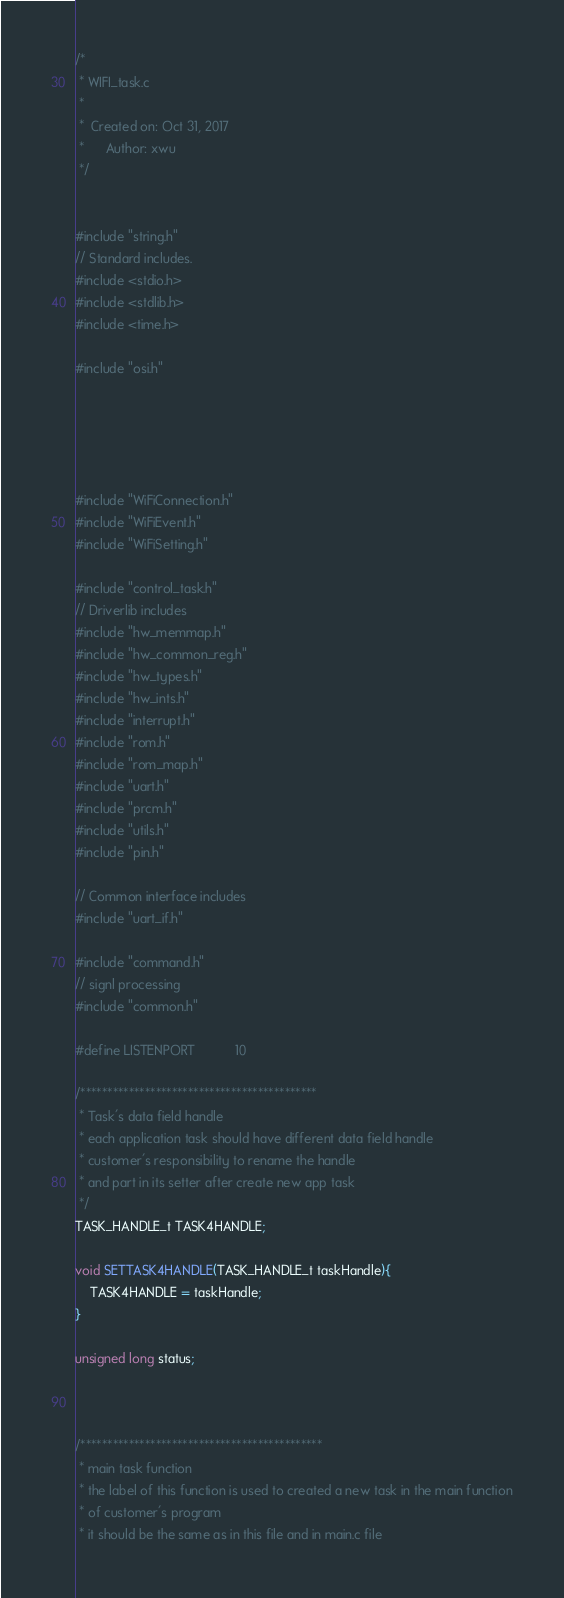<code> <loc_0><loc_0><loc_500><loc_500><_C_>/*
 * WIFI_task.c
 *
 *  Created on: Oct 31, 2017
 *      Author: xwu
 */


#include "string.h"
// Standard includes.
#include <stdio.h>
#include <stdlib.h>
#include <time.h>

#include "osi.h"





#include "WiFiConnection.h"
#include "WiFiEvent.h"
#include "WiFiSetting.h"

#include "control_task.h"
// Driverlib includes
#include "hw_memmap.h"
#include "hw_common_reg.h"
#include "hw_types.h"
#include "hw_ints.h"
#include "interrupt.h"
#include "rom.h"
#include "rom_map.h"
#include "uart.h"
#include "prcm.h"
#include "utils.h"
#include "pin.h"

// Common interface includes
#include "uart_if.h"

#include "command.h"
// signl processing
#include "common.h"

#define LISTENPORT			10

/********************************************
 * Task's data field handle
 * each application task should have different data field handle
 * customer's responsibility to rename the handle
 * and part in its setter after create new app task
 */
TASK_HANDLE_t TASK4HANDLE;

void SETTASK4HANDLE(TASK_HANDLE_t taskHandle){
	TASK4HANDLE = taskHandle;
}

unsigned long status;



/*********************************************
 * main task function
 * the label of this function is used to created a new task in the main function
 * of customer's program
 * it should be the same as in this file and in main.c file</code> 